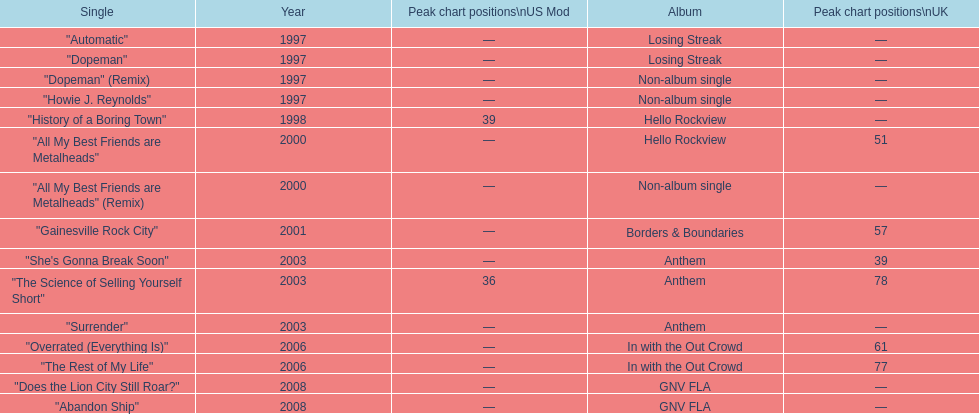Over how many years did the gap between the losing streak album and gnv fla occur? 11. Would you mind parsing the complete table? {'header': ['Single', 'Year', 'Peak chart positions\\nUS Mod', 'Album', 'Peak chart positions\\nUK'], 'rows': [['"Automatic"', '1997', '—', 'Losing Streak', '—'], ['"Dopeman"', '1997', '—', 'Losing Streak', '—'], ['"Dopeman" (Remix)', '1997', '—', 'Non-album single', '—'], ['"Howie J. Reynolds"', '1997', '—', 'Non-album single', '—'], ['"History of a Boring Town"', '1998', '39', 'Hello Rockview', '—'], ['"All My Best Friends are Metalheads"', '2000', '—', 'Hello Rockview', '51'], ['"All My Best Friends are Metalheads" (Remix)', '2000', '—', 'Non-album single', '—'], ['"Gainesville Rock City"', '2001', '—', 'Borders & Boundaries', '57'], ['"She\'s Gonna Break Soon"', '2003', '—', 'Anthem', '39'], ['"The Science of Selling Yourself Short"', '2003', '36', 'Anthem', '78'], ['"Surrender"', '2003', '—', 'Anthem', '—'], ['"Overrated (Everything Is)"', '2006', '—', 'In with the Out Crowd', '61'], ['"The Rest of My Life"', '2006', '—', 'In with the Out Crowd', '77'], ['"Does the Lion City Still Roar?"', '2008', '—', 'GNV FLA', '—'], ['"Abandon Ship"', '2008', '—', 'GNV FLA', '—']]} 